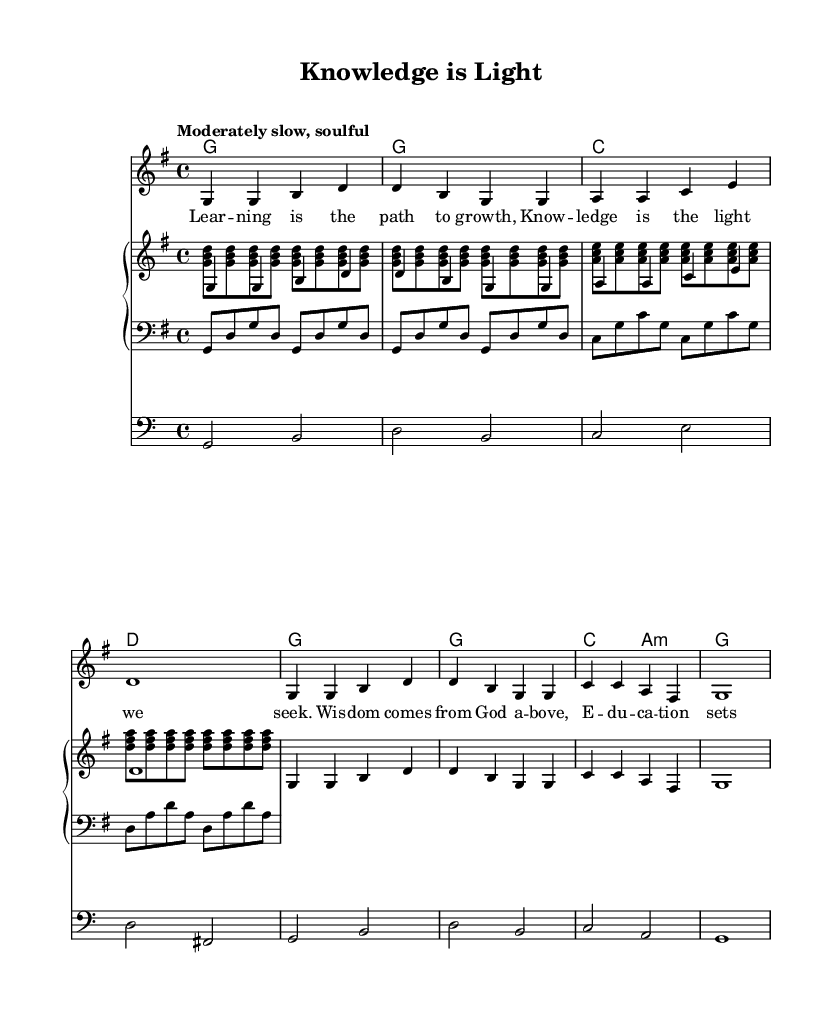What is the key signature of this music? The key signature is G major, which has one sharp (F#). This can be identified from the initial notation at the beginning of the score that indicates the key signature.
Answer: G major What is the time signature of this music? The time signature is 4/4, which means there are four beats in a measure and the quarter note gets one beat. This is indicated in the notation next to the clef at the beginning of the staff.
Answer: 4/4 What is the tempo marking for this piece? The tempo marking is "Moderately slow, soulful", which describes how the piece should be played. This is shown in the score near the global section.
Answer: Moderately slow, soulful How many measures are in the melody section? The melody section contains 6 measures as counted from the notation. Each measure is separated by vertical lines, making it easy to count.
Answer: 6 In which voice do the lyrics appear? The lyrics appear in the melody voice, indicated by the inclusion of "Lyrics" and the corresponding melody line in the musical score. The lyrics are sung along with the melody, making it a vocal piece.
Answer: Melody 